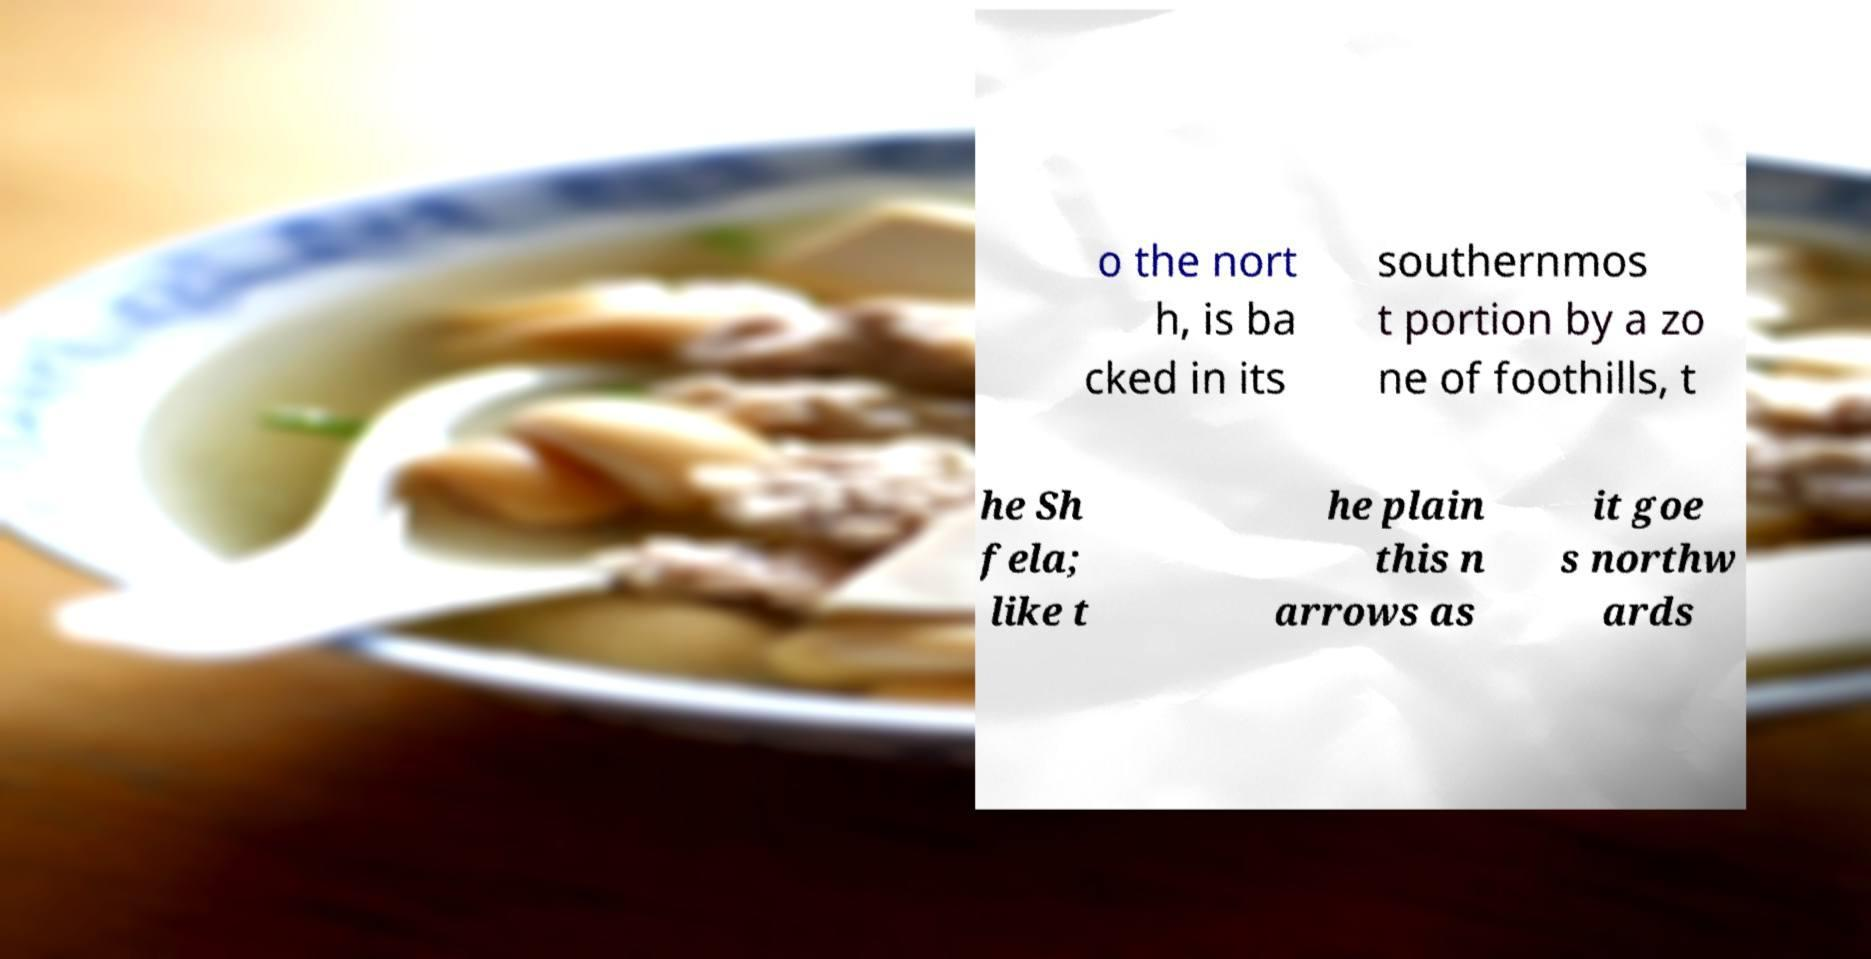I need the written content from this picture converted into text. Can you do that? o the nort h, is ba cked in its southernmos t portion by a zo ne of foothills, t he Sh fela; like t he plain this n arrows as it goe s northw ards 